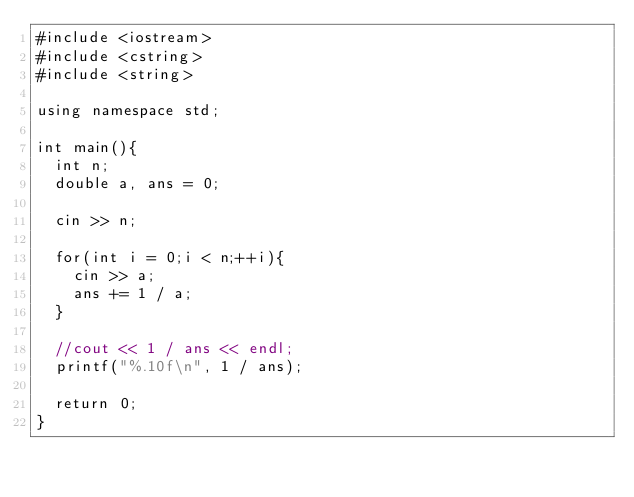Convert code to text. <code><loc_0><loc_0><loc_500><loc_500><_C++_>#include <iostream>
#include <cstring>
#include <string>

using namespace std;

int main(){
  int n;
  double a, ans = 0;

  cin >> n;

  for(int i = 0;i < n;++i){
    cin >> a;
    ans += 1 / a;
  }

  //cout << 1 / ans << endl;
  printf("%.10f\n", 1 / ans);

  return 0;
}
</code> 